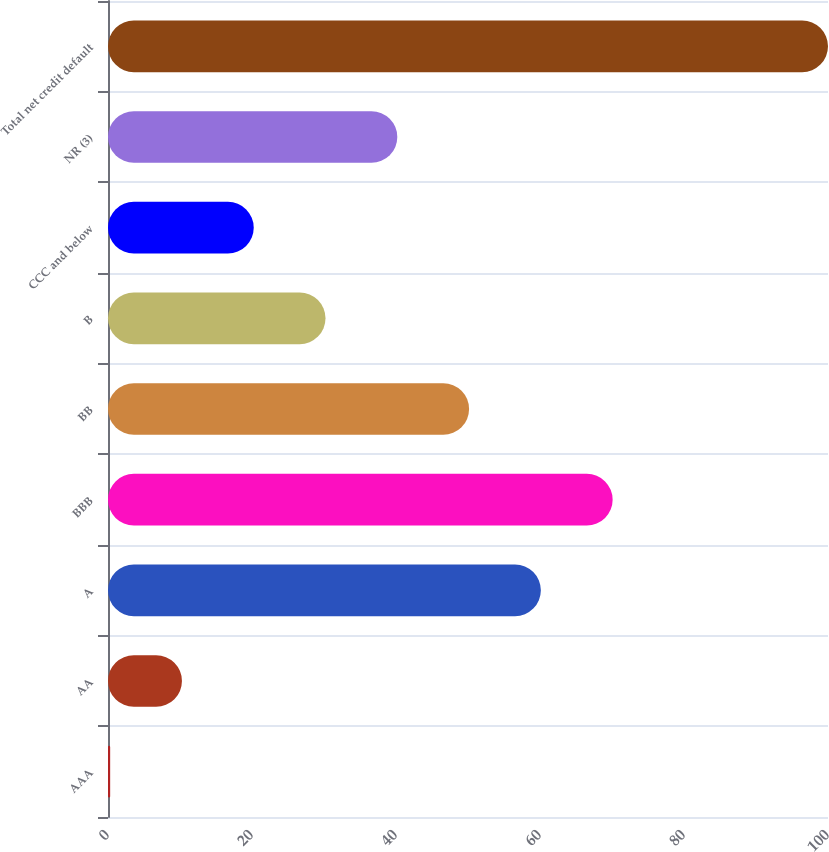Convert chart to OTSL. <chart><loc_0><loc_0><loc_500><loc_500><bar_chart><fcel>AAA<fcel>AA<fcel>A<fcel>BBB<fcel>BB<fcel>B<fcel>CCC and below<fcel>NR (3)<fcel>Total net credit default<nl><fcel>0.3<fcel>10.27<fcel>60.12<fcel>70.09<fcel>50.15<fcel>30.21<fcel>20.24<fcel>40.18<fcel>100<nl></chart> 